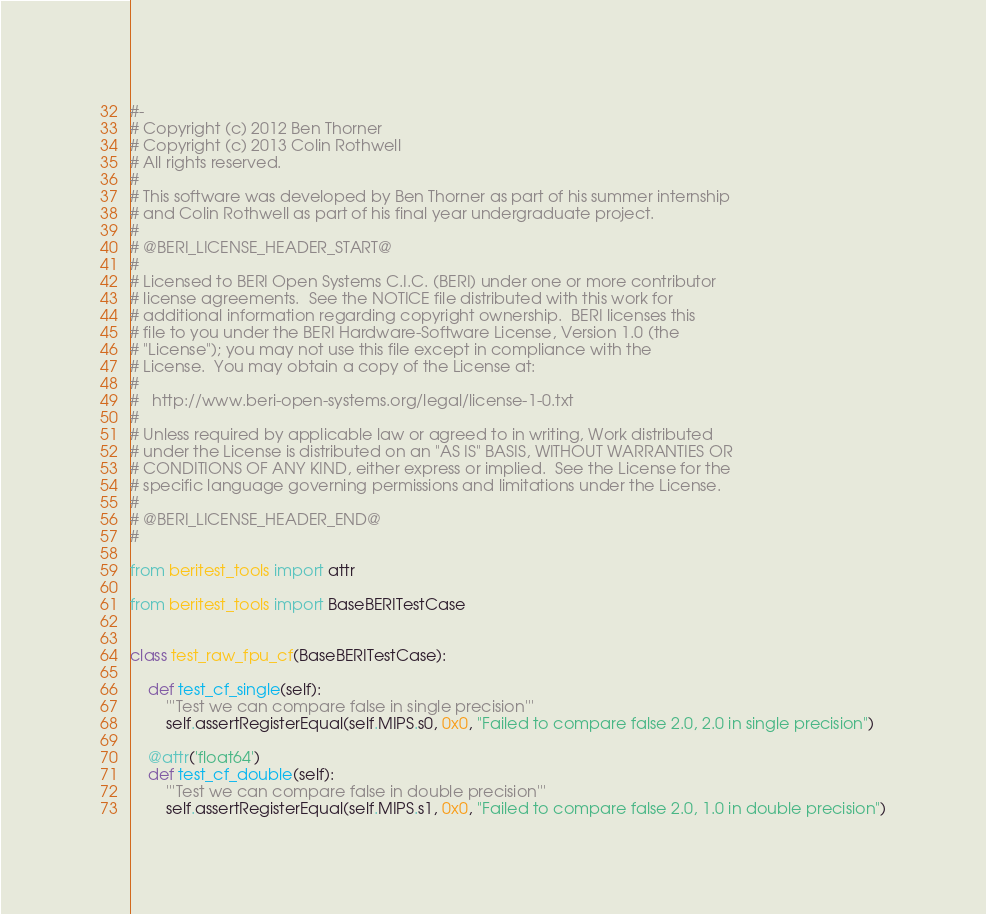<code> <loc_0><loc_0><loc_500><loc_500><_Python_>#-
# Copyright (c) 2012 Ben Thorner
# Copyright (c) 2013 Colin Rothwell
# All rights reserved.
#
# This software was developed by Ben Thorner as part of his summer internship
# and Colin Rothwell as part of his final year undergraduate project.
# 
# @BERI_LICENSE_HEADER_START@
#
# Licensed to BERI Open Systems C.I.C. (BERI) under one or more contributor
# license agreements.  See the NOTICE file distributed with this work for
# additional information regarding copyright ownership.  BERI licenses this
# file to you under the BERI Hardware-Software License, Version 1.0 (the
# "License"); you may not use this file except in compliance with the
# License.  You may obtain a copy of the License at:
#
#   http://www.beri-open-systems.org/legal/license-1-0.txt
#
# Unless required by applicable law or agreed to in writing, Work distributed
# under the License is distributed on an "AS IS" BASIS, WITHOUT WARRANTIES OR
# CONDITIONS OF ANY KIND, either express or implied.  See the License for the
# specific language governing permissions and limitations under the License.
#
# @BERI_LICENSE_HEADER_END@
#

from beritest_tools import attr

from beritest_tools import BaseBERITestCase


class test_raw_fpu_cf(BaseBERITestCase):

    def test_cf_single(self):
        '''Test we can compare false in single precision'''
        self.assertRegisterEqual(self.MIPS.s0, 0x0, "Failed to compare false 2.0, 2.0 in single precision")

    @attr('float64')
    def test_cf_double(self):
        '''Test we can compare false in double precision'''
        self.assertRegisterEqual(self.MIPS.s1, 0x0, "Failed to compare false 2.0, 1.0 in double precision")
</code> 